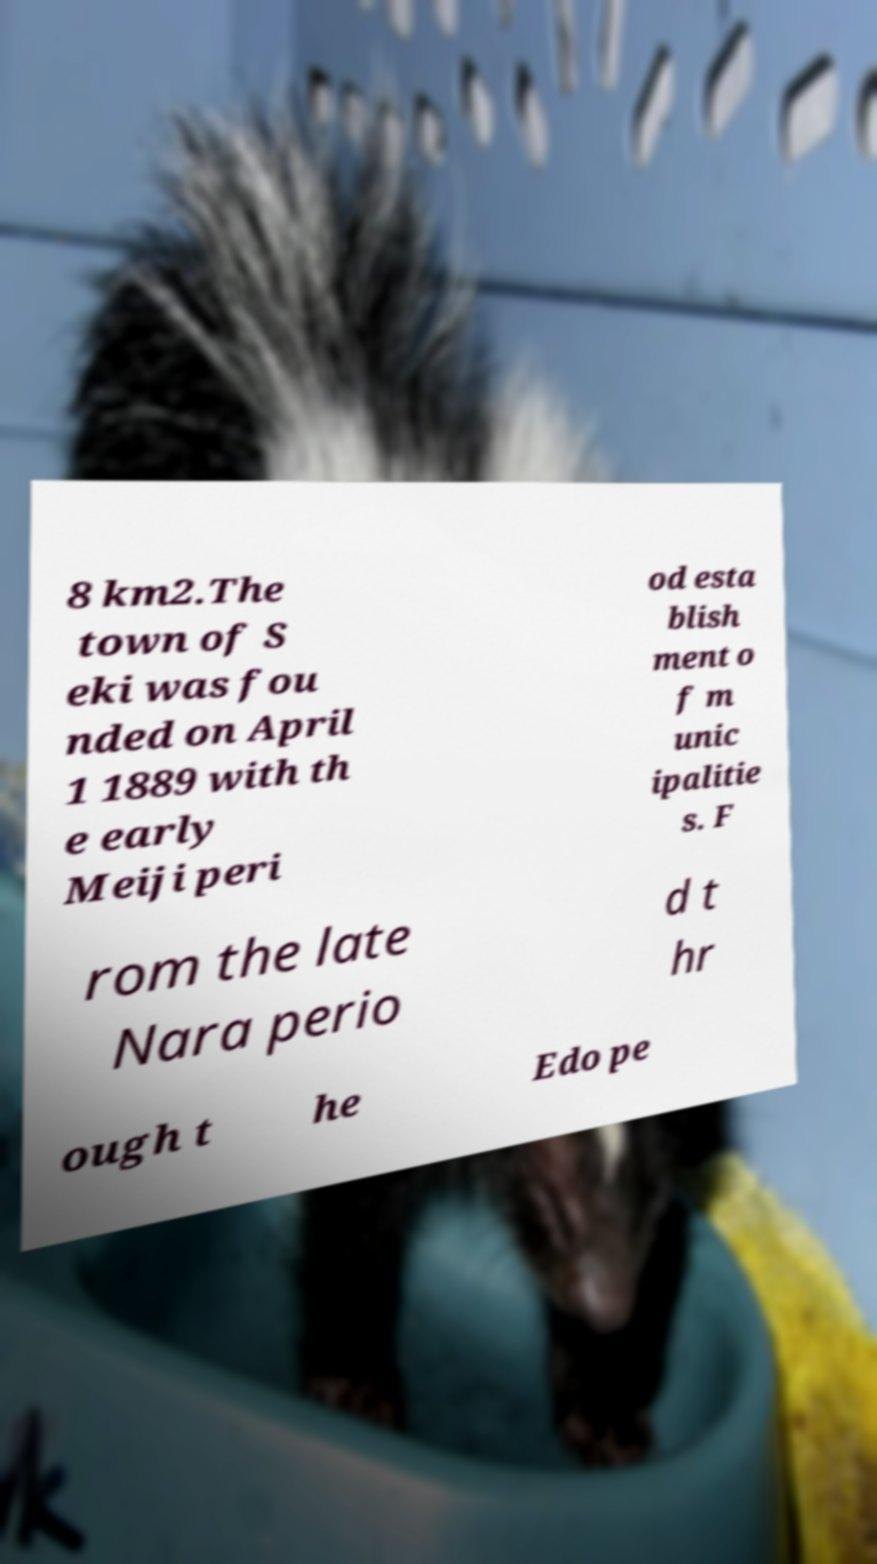Could you extract and type out the text from this image? 8 km2.The town of S eki was fou nded on April 1 1889 with th e early Meiji peri od esta blish ment o f m unic ipalitie s. F rom the late Nara perio d t hr ough t he Edo pe 